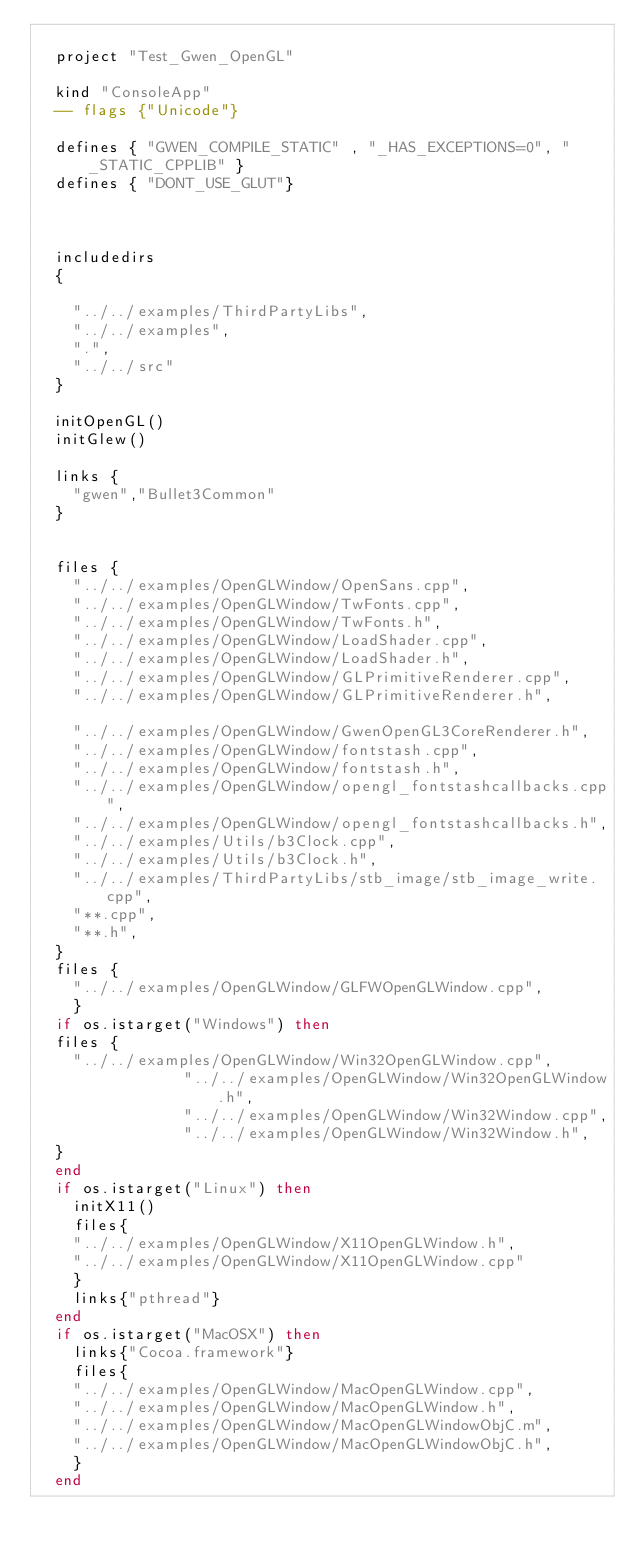Convert code to text. <code><loc_0><loc_0><loc_500><loc_500><_Lua_>
	project "Test_Gwen_OpenGL"
		
	kind "ConsoleApp"
	-- flags {"Unicode"}
	
	defines { "GWEN_COMPILE_STATIC" , "_HAS_EXCEPTIONS=0", "_STATIC_CPPLIB" }
	defines { "DONT_USE_GLUT"}
	
	
	
	includedirs 
	{
	
		"../../examples/ThirdPartyLibs",
		"../../examples",	
		".",
		"../../src"
	}

	initOpenGL()
	initGlew()
			
	links {
		"gwen","Bullet3Common"
	}
	
	
	files {
		"../../examples/OpenGLWindow/OpenSans.cpp",
		"../../examples/OpenGLWindow/TwFonts.cpp",
		"../../examples/OpenGLWindow/TwFonts.h",
		"../../examples/OpenGLWindow/LoadShader.cpp",
		"../../examples/OpenGLWindow/LoadShader.h",
		"../../examples/OpenGLWindow/GLPrimitiveRenderer.cpp",
		"../../examples/OpenGLWindow/GLPrimitiveRenderer.h",				
		"../../examples/OpenGLWindow/GwenOpenGL3CoreRenderer.h",
		"../../examples/OpenGLWindow/fontstash.cpp",
		"../../examples/OpenGLWindow/fontstash.h",
		"../../examples/OpenGLWindow/opengl_fontstashcallbacks.cpp",
 		"../../examples/OpenGLWindow/opengl_fontstashcallbacks.h",
		"../../examples/Utils/b3Clock.cpp",
		"../../examples/Utils/b3Clock.h",
		"../../examples/ThirdPartyLibs/stb_image/stb_image_write.cpp",
		"**.cpp",
		"**.h",
	}
	files {
		"../../examples/OpenGLWindow/GLFWOpenGLWindow.cpp",
		}
	if os.istarget("Windows") then
	files {
		"../../examples/OpenGLWindow/Win32OpenGLWindow.cpp",
                "../../examples/OpenGLWindow/Win32OpenGLWindow.h",
                "../../examples/OpenGLWindow/Win32Window.cpp",
                "../../examples/OpenGLWindow/Win32Window.h",
	}
	end
	if os.istarget("Linux") then 
		initX11()
		files{
		"../../examples/OpenGLWindow/X11OpenGLWindow.h",
		"../../examples/OpenGLWindow/X11OpenGLWindow.cpp"
		}
		links{"pthread"}
	end
	if os.istarget("MacOSX") then
		links{"Cocoa.framework"}
		files{
		"../../examples/OpenGLWindow/MacOpenGLWindow.cpp",
		"../../examples/OpenGLWindow/MacOpenGLWindow.h",
		"../../examples/OpenGLWindow/MacOpenGLWindowObjC.m",
		"../../examples/OpenGLWindow/MacOpenGLWindowObjC.h",
		}
	end
</code> 